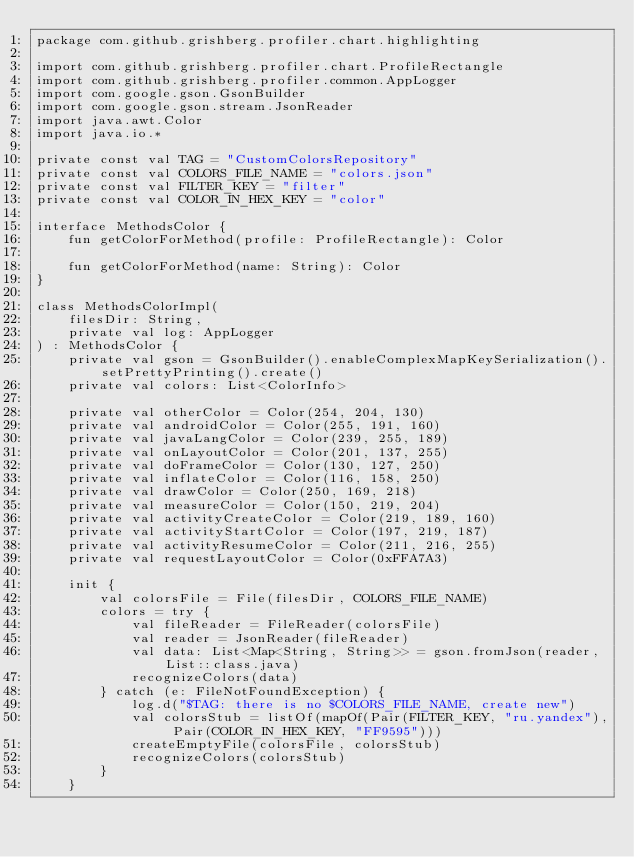<code> <loc_0><loc_0><loc_500><loc_500><_Kotlin_>package com.github.grishberg.profiler.chart.highlighting

import com.github.grishberg.profiler.chart.ProfileRectangle
import com.github.grishberg.profiler.common.AppLogger
import com.google.gson.GsonBuilder
import com.google.gson.stream.JsonReader
import java.awt.Color
import java.io.*

private const val TAG = "CustomColorsRepository"
private const val COLORS_FILE_NAME = "colors.json"
private const val FILTER_KEY = "filter"
private const val COLOR_IN_HEX_KEY = "color"

interface MethodsColor {
    fun getColorForMethod(profile: ProfileRectangle): Color

    fun getColorForMethod(name: String): Color
}

class MethodsColorImpl(
    filesDir: String,
    private val log: AppLogger
) : MethodsColor {
    private val gson = GsonBuilder().enableComplexMapKeySerialization().setPrettyPrinting().create()
    private val colors: List<ColorInfo>

    private val otherColor = Color(254, 204, 130)
    private val androidColor = Color(255, 191, 160)
    private val javaLangColor = Color(239, 255, 189)
    private val onLayoutColor = Color(201, 137, 255)
    private val doFrameColor = Color(130, 127, 250)
    private val inflateColor = Color(116, 158, 250)
    private val drawColor = Color(250, 169, 218)
    private val measureColor = Color(150, 219, 204)
    private val activityCreateColor = Color(219, 189, 160)
    private val activityStartColor = Color(197, 219, 187)
    private val activityResumeColor = Color(211, 216, 255)
    private val requestLayoutColor = Color(0xFFA7A3)

    init {
        val colorsFile = File(filesDir, COLORS_FILE_NAME)
        colors = try {
            val fileReader = FileReader(colorsFile)
            val reader = JsonReader(fileReader)
            val data: List<Map<String, String>> = gson.fromJson(reader, List::class.java)
            recognizeColors(data)
        } catch (e: FileNotFoundException) {
            log.d("$TAG: there is no $COLORS_FILE_NAME, create new")
            val colorsStub = listOf(mapOf(Pair(FILTER_KEY, "ru.yandex"), Pair(COLOR_IN_HEX_KEY, "FF9595")))
            createEmptyFile(colorsFile, colorsStub)
            recognizeColors(colorsStub)
        }
    }
</code> 